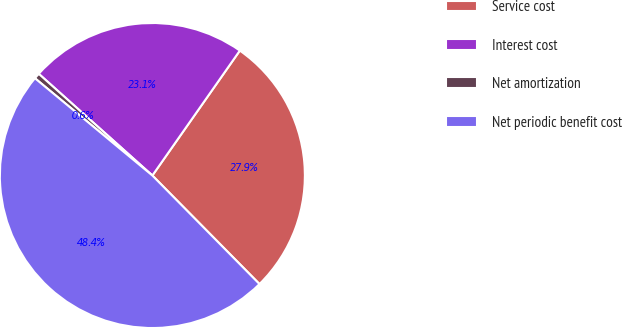Convert chart to OTSL. <chart><loc_0><loc_0><loc_500><loc_500><pie_chart><fcel>Service cost<fcel>Interest cost<fcel>Net amortization<fcel>Net periodic benefit cost<nl><fcel>27.88%<fcel>23.1%<fcel>0.61%<fcel>48.4%<nl></chart> 